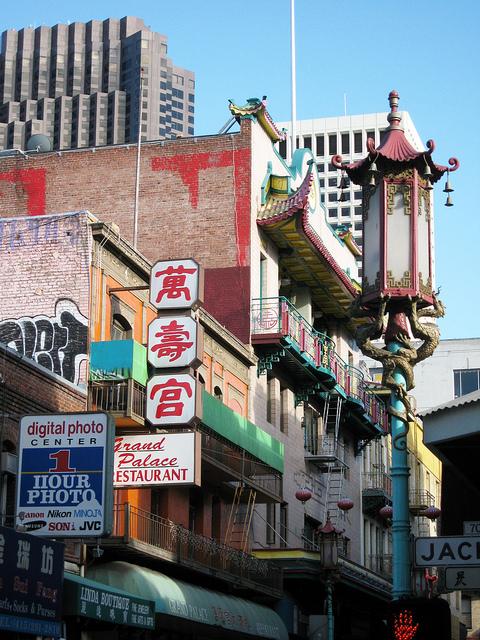What is the name of the restaurant to the left?
Short answer required. Grand palace. What will take 1 hour?
Keep it brief. Photo. What does the red hand at the bottom of the photo indicate?
Short answer required. Don't walk. 